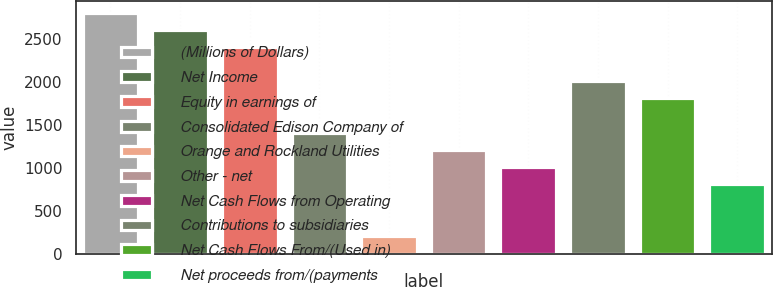Convert chart to OTSL. <chart><loc_0><loc_0><loc_500><loc_500><bar_chart><fcel>(Millions of Dollars)<fcel>Net Income<fcel>Equity in earnings of<fcel>Consolidated Edison Company of<fcel>Orange and Rockland Utilities<fcel>Other - net<fcel>Net Cash Flows from Operating<fcel>Contributions to subsidiaries<fcel>Net Cash Flows From/(Used in)<fcel>Net proceeds from/(payments<nl><fcel>2805.2<fcel>2605.9<fcel>2406.6<fcel>1410.1<fcel>214.3<fcel>1210.8<fcel>1011.5<fcel>2008<fcel>1808.7<fcel>812.2<nl></chart> 